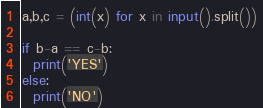<code> <loc_0><loc_0><loc_500><loc_500><_Python_>a,b,c = (int(x) for x in input().split())

if b-a == c-b:
  print('YES')
else:
  print('NO')</code> 